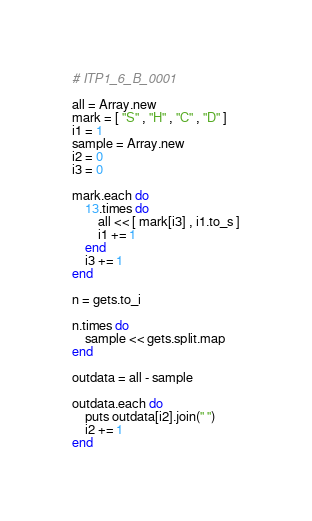<code> <loc_0><loc_0><loc_500><loc_500><_Ruby_># ITP1_6_B_0001

all = Array.new
mark = [ "S" , "H" , "C" , "D" ]
i1 = 1
sample = Array.new
i2 = 0
i3 = 0

mark.each do
	13.times do
		all << [ mark[i3] , i1.to_s ]
		i1 += 1
	end
	i3 += 1
end

n = gets.to_i

n.times do
	sample << gets.split.map
end

outdata = all - sample

outdata.each do
	puts outdata[i2].join(" ")
	i2 += 1
end</code> 